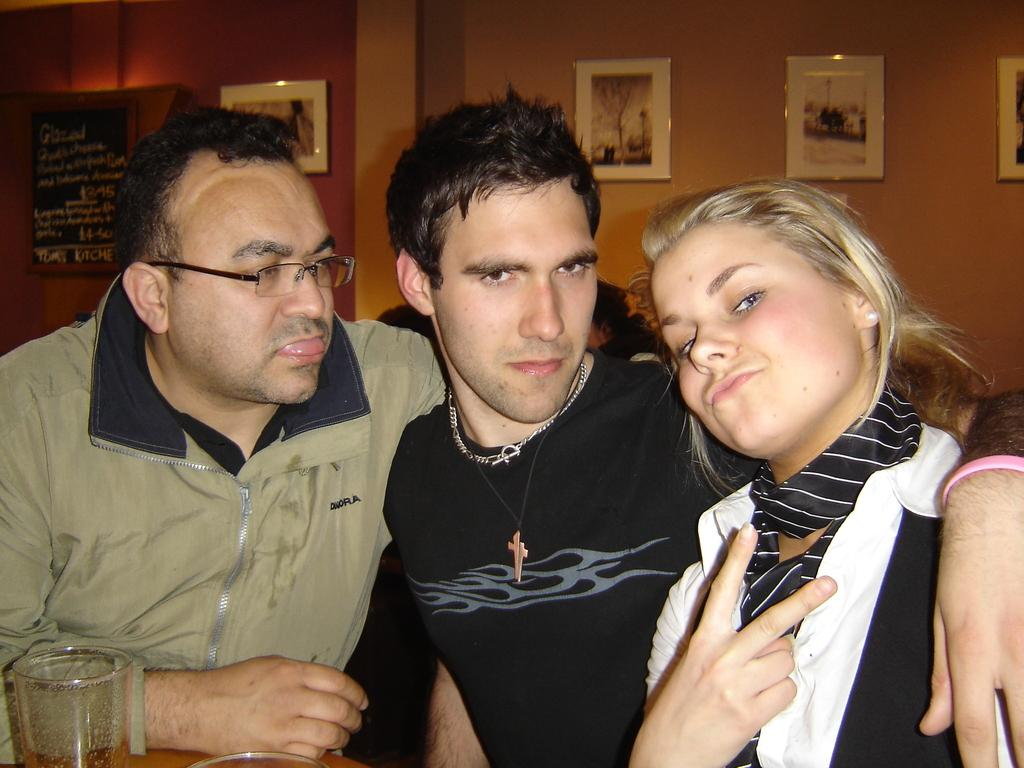How many people are in the image? There are three persons in the image. What are the persons doing in the image? The persons are sitting in front of a table. What objects can be seen on the table? There is a glass and a bowl on the table. What can be seen hanging on the wall in the background? There are frames hanging on the wall in the background. Can you tell me how many times the persons in the image touch the glass during the game? There is no game or touching of the glass depicted in the image; the persons are simply sitting in front of a table with a glass and a bowl. 